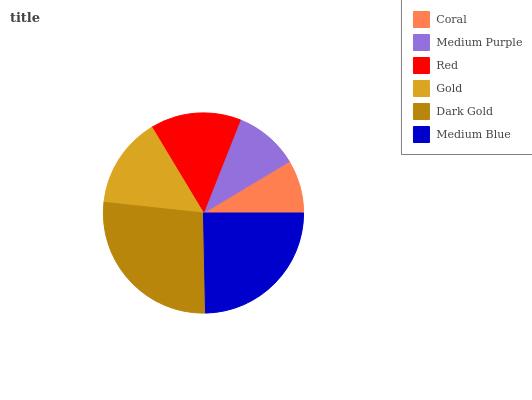Is Coral the minimum?
Answer yes or no. Yes. Is Dark Gold the maximum?
Answer yes or no. Yes. Is Medium Purple the minimum?
Answer yes or no. No. Is Medium Purple the maximum?
Answer yes or no. No. Is Medium Purple greater than Coral?
Answer yes or no. Yes. Is Coral less than Medium Purple?
Answer yes or no. Yes. Is Coral greater than Medium Purple?
Answer yes or no. No. Is Medium Purple less than Coral?
Answer yes or no. No. Is Gold the high median?
Answer yes or no. Yes. Is Red the low median?
Answer yes or no. Yes. Is Medium Purple the high median?
Answer yes or no. No. Is Medium Blue the low median?
Answer yes or no. No. 